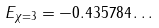<formula> <loc_0><loc_0><loc_500><loc_500>E _ { \chi = 3 } = - 0 . 4 3 5 7 8 4 \dots</formula> 